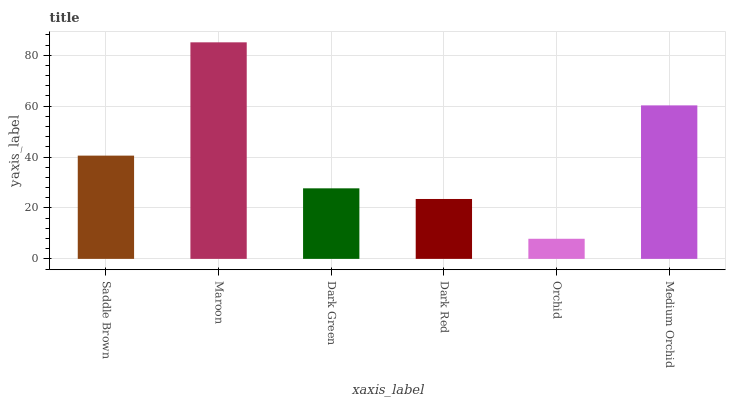Is Orchid the minimum?
Answer yes or no. Yes. Is Maroon the maximum?
Answer yes or no. Yes. Is Dark Green the minimum?
Answer yes or no. No. Is Dark Green the maximum?
Answer yes or no. No. Is Maroon greater than Dark Green?
Answer yes or no. Yes. Is Dark Green less than Maroon?
Answer yes or no. Yes. Is Dark Green greater than Maroon?
Answer yes or no. No. Is Maroon less than Dark Green?
Answer yes or no. No. Is Saddle Brown the high median?
Answer yes or no. Yes. Is Dark Green the low median?
Answer yes or no. Yes. Is Orchid the high median?
Answer yes or no. No. Is Dark Red the low median?
Answer yes or no. No. 